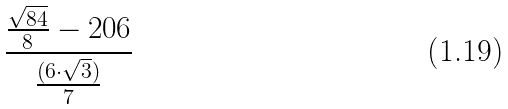Convert formula to latex. <formula><loc_0><loc_0><loc_500><loc_500>\frac { \frac { \sqrt { 8 4 } } { 8 } - 2 0 6 } { \frac { ( 6 \cdot \sqrt { 3 } ) } { 7 } }</formula> 